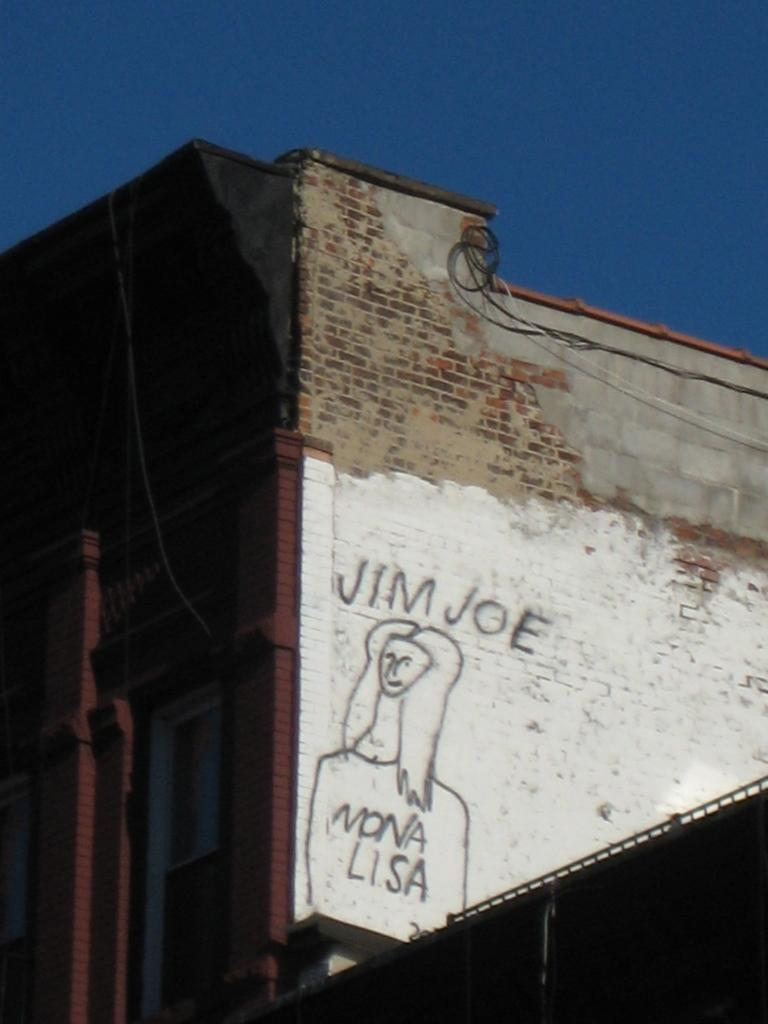What type of structure is present in the image? There is a building in the image. What else can be seen in the image besides the building? There is a drawing of a woman in the image. What part of the natural environment is visible in the image? The sky is visible in the image. How many dolls are playing with the hose in the image? There are no dolls or hoses present in the image. 